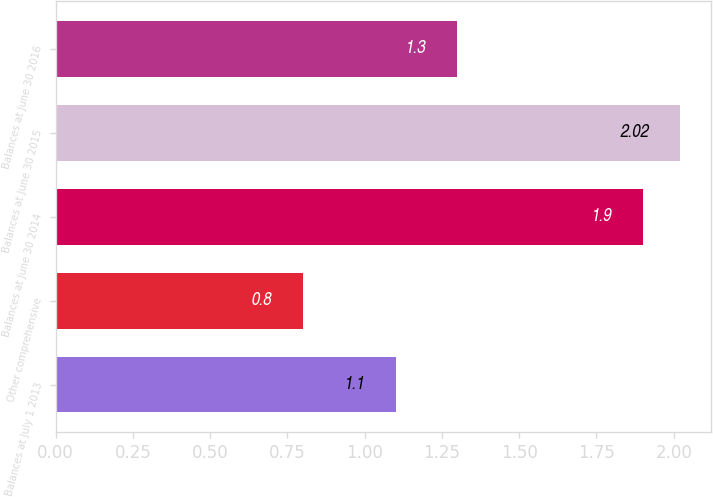<chart> <loc_0><loc_0><loc_500><loc_500><bar_chart><fcel>Balances at July 1 2013<fcel>Other comprehensive<fcel>Balances at June 30 2014<fcel>Balances at June 30 2015<fcel>Balances at June 30 2016<nl><fcel>1.1<fcel>0.8<fcel>1.9<fcel>2.02<fcel>1.3<nl></chart> 